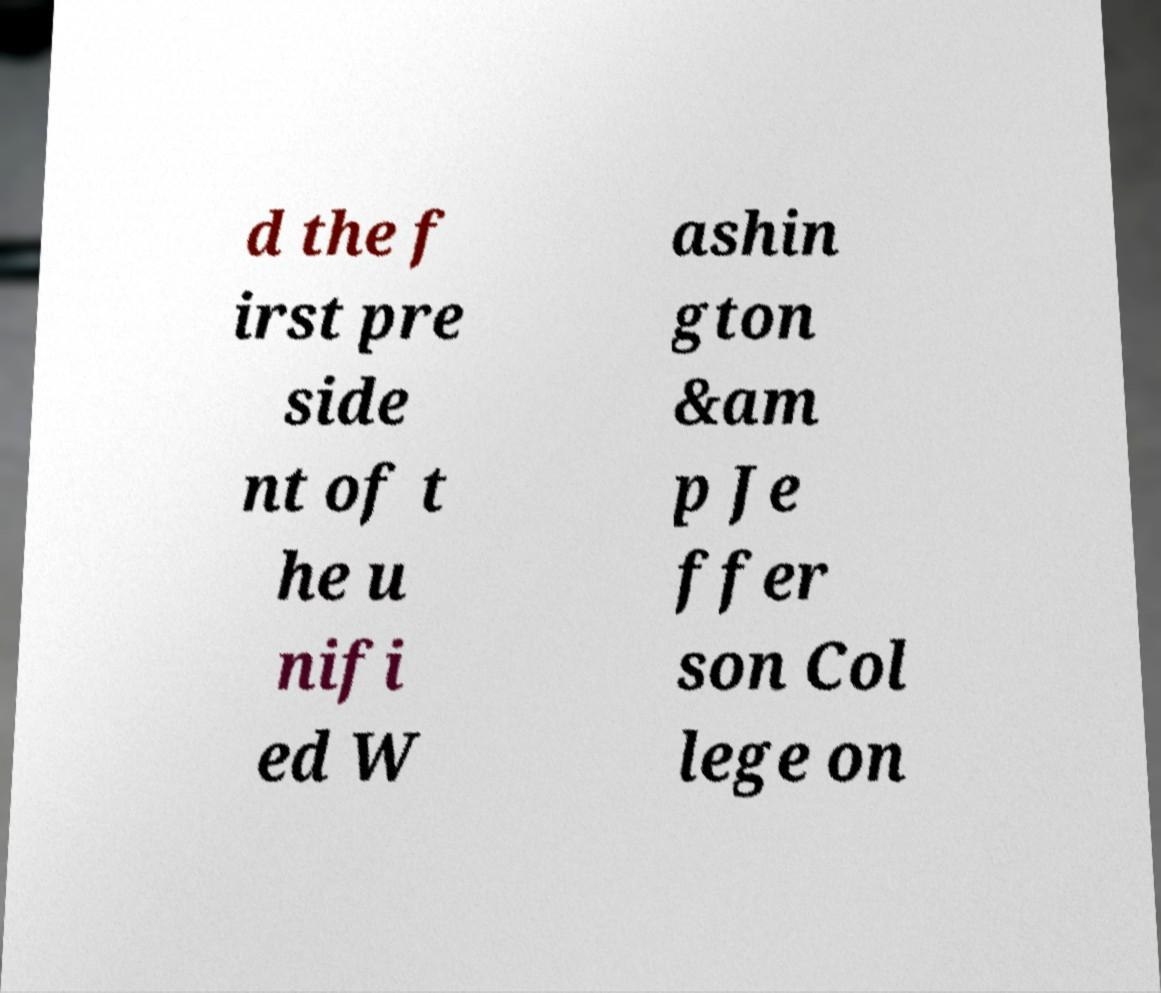Could you extract and type out the text from this image? d the f irst pre side nt of t he u nifi ed W ashin gton &am p Je ffer son Col lege on 